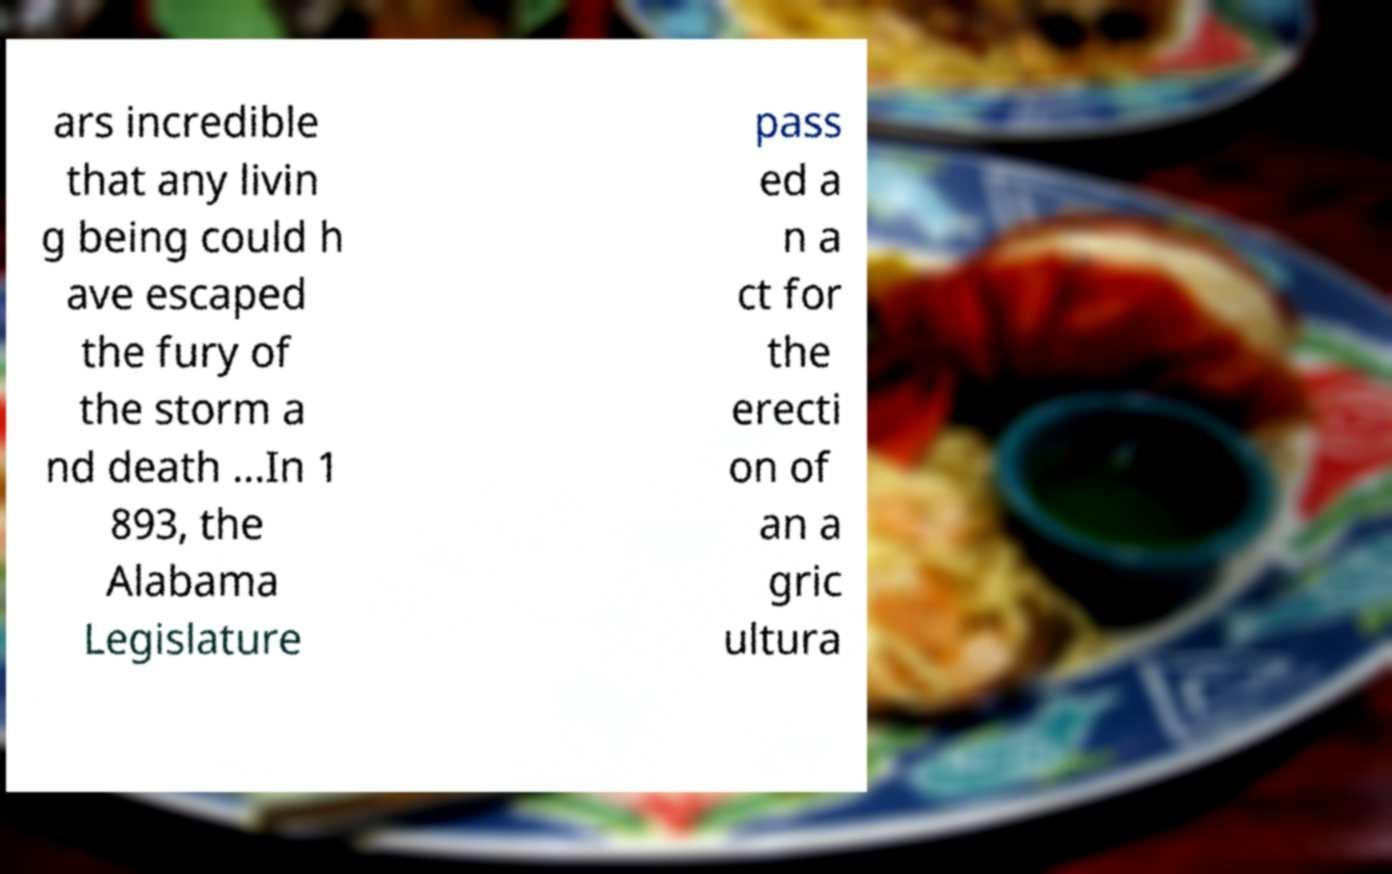Could you assist in decoding the text presented in this image and type it out clearly? ars incredible that any livin g being could h ave escaped the fury of the storm a nd death ...In 1 893, the Alabama Legislature pass ed a n a ct for the erecti on of an a gric ultura 